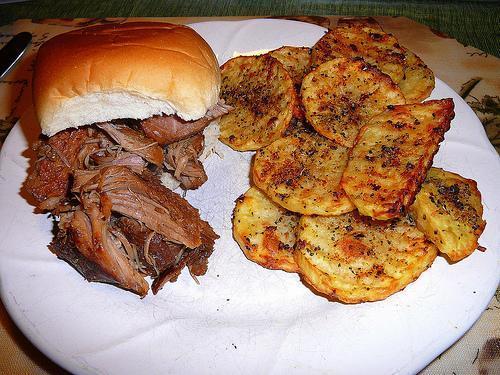How many sandwiches are in the picture?
Give a very brief answer. 1. How many potato wedges are visible?
Give a very brief answer. 9. How many buns are in the image?
Give a very brief answer. 1. How many kangaroos are in the picture?
Give a very brief answer. 0. 